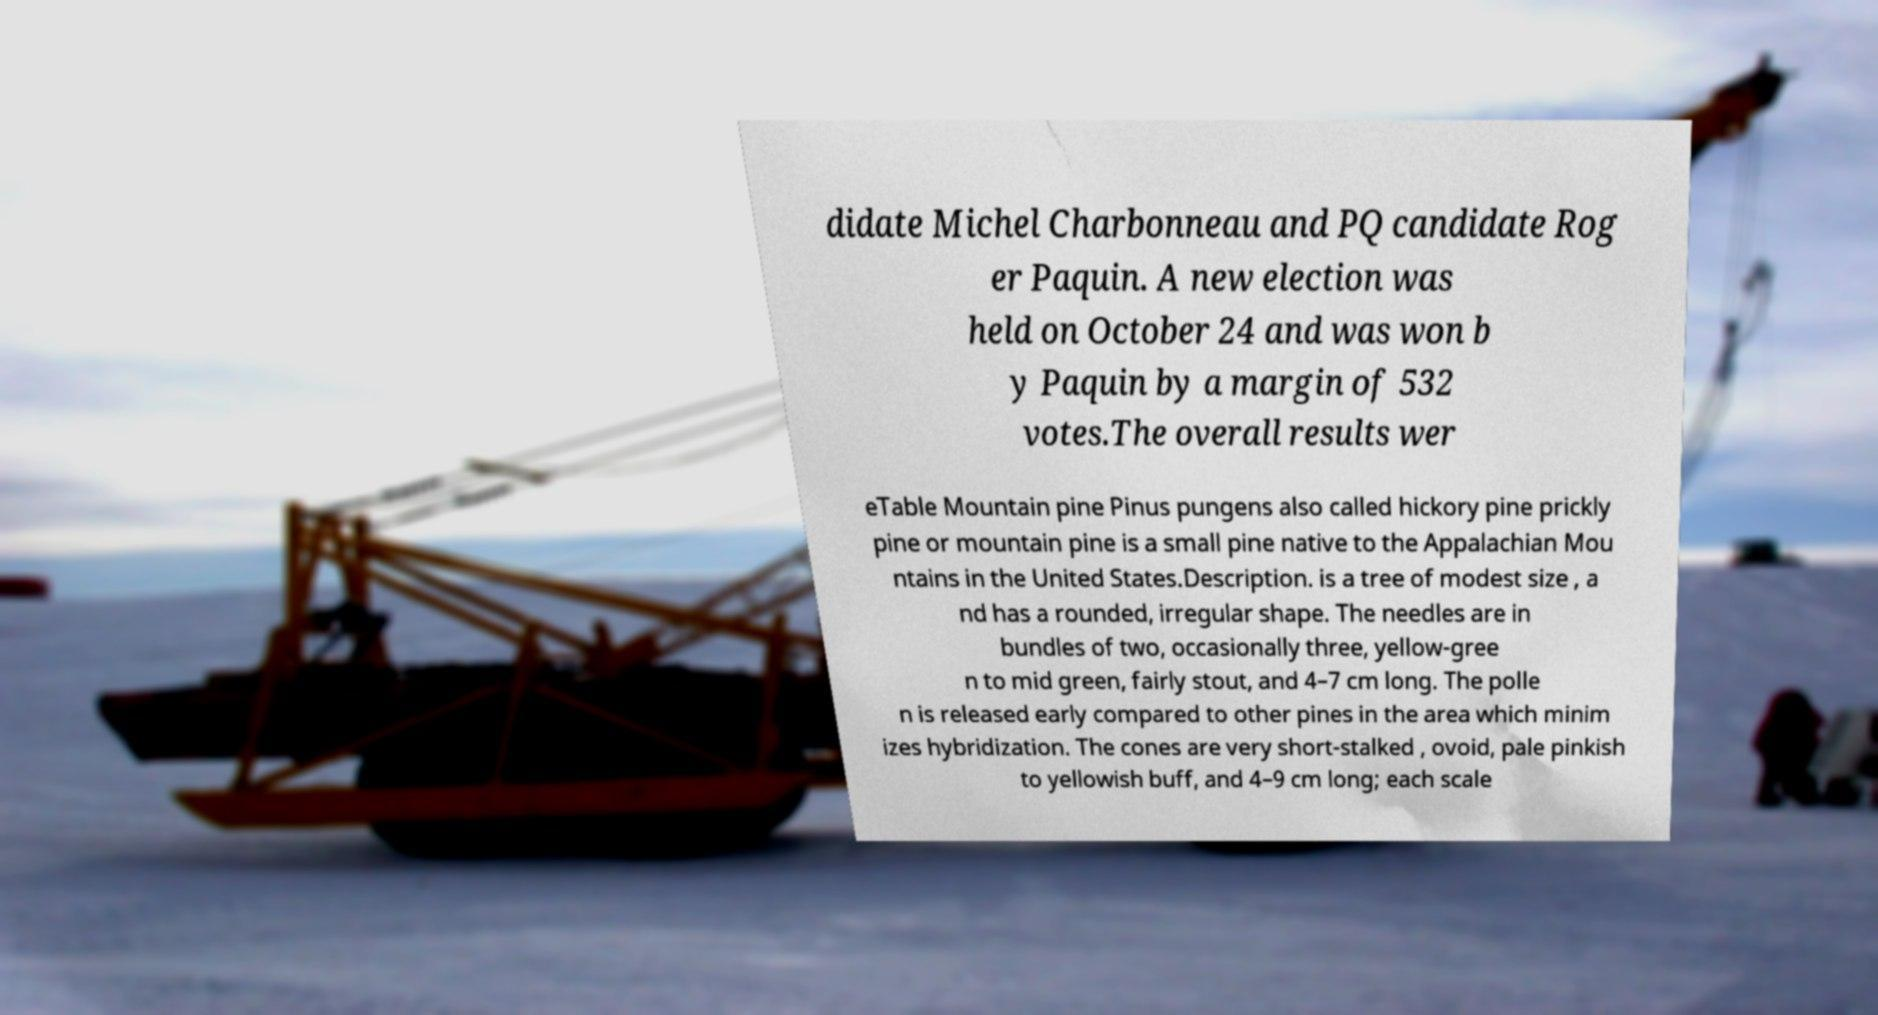Can you read and provide the text displayed in the image?This photo seems to have some interesting text. Can you extract and type it out for me? didate Michel Charbonneau and PQ candidate Rog er Paquin. A new election was held on October 24 and was won b y Paquin by a margin of 532 votes.The overall results wer eTable Mountain pine Pinus pungens also called hickory pine prickly pine or mountain pine is a small pine native to the Appalachian Mou ntains in the United States.Description. is a tree of modest size , a nd has a rounded, irregular shape. The needles are in bundles of two, occasionally three, yellow-gree n to mid green, fairly stout, and 4–7 cm long. The polle n is released early compared to other pines in the area which minim izes hybridization. The cones are very short-stalked , ovoid, pale pinkish to yellowish buff, and 4–9 cm long; each scale 